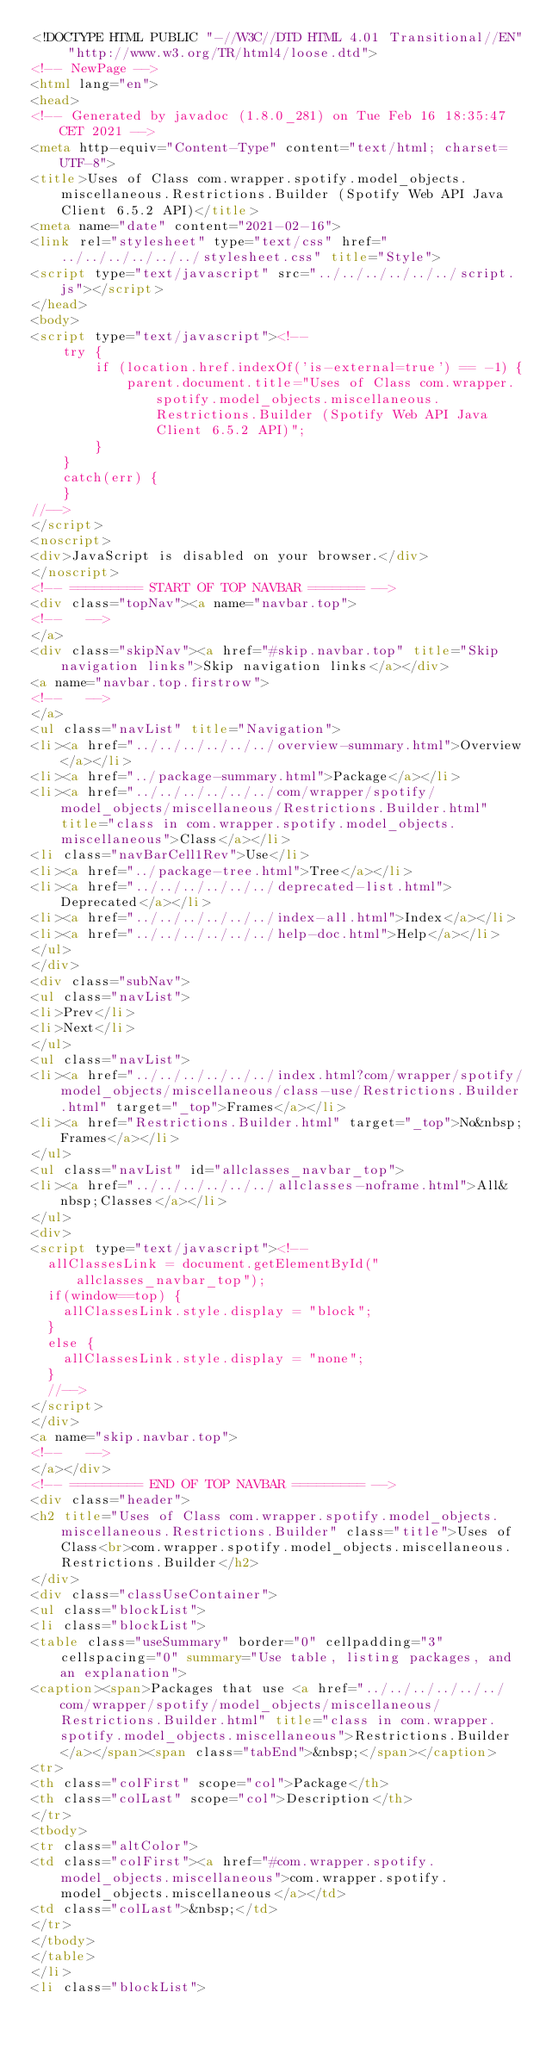Convert code to text. <code><loc_0><loc_0><loc_500><loc_500><_HTML_><!DOCTYPE HTML PUBLIC "-//W3C//DTD HTML 4.01 Transitional//EN" "http://www.w3.org/TR/html4/loose.dtd">
<!-- NewPage -->
<html lang="en">
<head>
<!-- Generated by javadoc (1.8.0_281) on Tue Feb 16 18:35:47 CET 2021 -->
<meta http-equiv="Content-Type" content="text/html; charset=UTF-8">
<title>Uses of Class com.wrapper.spotify.model_objects.miscellaneous.Restrictions.Builder (Spotify Web API Java Client 6.5.2 API)</title>
<meta name="date" content="2021-02-16">
<link rel="stylesheet" type="text/css" href="../../../../../../stylesheet.css" title="Style">
<script type="text/javascript" src="../../../../../../script.js"></script>
</head>
<body>
<script type="text/javascript"><!--
    try {
        if (location.href.indexOf('is-external=true') == -1) {
            parent.document.title="Uses of Class com.wrapper.spotify.model_objects.miscellaneous.Restrictions.Builder (Spotify Web API Java Client 6.5.2 API)";
        }
    }
    catch(err) {
    }
//-->
</script>
<noscript>
<div>JavaScript is disabled on your browser.</div>
</noscript>
<!-- ========= START OF TOP NAVBAR ======= -->
<div class="topNav"><a name="navbar.top">
<!--   -->
</a>
<div class="skipNav"><a href="#skip.navbar.top" title="Skip navigation links">Skip navigation links</a></div>
<a name="navbar.top.firstrow">
<!--   -->
</a>
<ul class="navList" title="Navigation">
<li><a href="../../../../../../overview-summary.html">Overview</a></li>
<li><a href="../package-summary.html">Package</a></li>
<li><a href="../../../../../../com/wrapper/spotify/model_objects/miscellaneous/Restrictions.Builder.html" title="class in com.wrapper.spotify.model_objects.miscellaneous">Class</a></li>
<li class="navBarCell1Rev">Use</li>
<li><a href="../package-tree.html">Tree</a></li>
<li><a href="../../../../../../deprecated-list.html">Deprecated</a></li>
<li><a href="../../../../../../index-all.html">Index</a></li>
<li><a href="../../../../../../help-doc.html">Help</a></li>
</ul>
</div>
<div class="subNav">
<ul class="navList">
<li>Prev</li>
<li>Next</li>
</ul>
<ul class="navList">
<li><a href="../../../../../../index.html?com/wrapper/spotify/model_objects/miscellaneous/class-use/Restrictions.Builder.html" target="_top">Frames</a></li>
<li><a href="Restrictions.Builder.html" target="_top">No&nbsp;Frames</a></li>
</ul>
<ul class="navList" id="allclasses_navbar_top">
<li><a href="../../../../../../allclasses-noframe.html">All&nbsp;Classes</a></li>
</ul>
<div>
<script type="text/javascript"><!--
  allClassesLink = document.getElementById("allclasses_navbar_top");
  if(window==top) {
    allClassesLink.style.display = "block";
  }
  else {
    allClassesLink.style.display = "none";
  }
  //-->
</script>
</div>
<a name="skip.navbar.top">
<!--   -->
</a></div>
<!-- ========= END OF TOP NAVBAR ========= -->
<div class="header">
<h2 title="Uses of Class com.wrapper.spotify.model_objects.miscellaneous.Restrictions.Builder" class="title">Uses of Class<br>com.wrapper.spotify.model_objects.miscellaneous.Restrictions.Builder</h2>
</div>
<div class="classUseContainer">
<ul class="blockList">
<li class="blockList">
<table class="useSummary" border="0" cellpadding="3" cellspacing="0" summary="Use table, listing packages, and an explanation">
<caption><span>Packages that use <a href="../../../../../../com/wrapper/spotify/model_objects/miscellaneous/Restrictions.Builder.html" title="class in com.wrapper.spotify.model_objects.miscellaneous">Restrictions.Builder</a></span><span class="tabEnd">&nbsp;</span></caption>
<tr>
<th class="colFirst" scope="col">Package</th>
<th class="colLast" scope="col">Description</th>
</tr>
<tbody>
<tr class="altColor">
<td class="colFirst"><a href="#com.wrapper.spotify.model_objects.miscellaneous">com.wrapper.spotify.model_objects.miscellaneous</a></td>
<td class="colLast">&nbsp;</td>
</tr>
</tbody>
</table>
</li>
<li class="blockList"></code> 